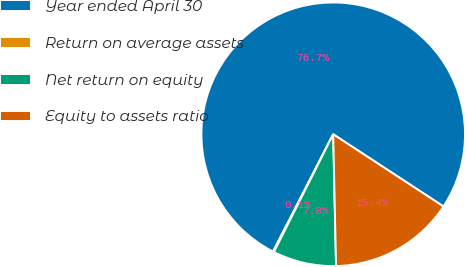Convert chart. <chart><loc_0><loc_0><loc_500><loc_500><pie_chart><fcel>Year ended April 30<fcel>Return on average assets<fcel>Net return on equity<fcel>Equity to assets ratio<nl><fcel>76.68%<fcel>0.12%<fcel>7.77%<fcel>15.43%<nl></chart> 